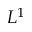Convert formula to latex. <formula><loc_0><loc_0><loc_500><loc_500>L ^ { 1 }</formula> 